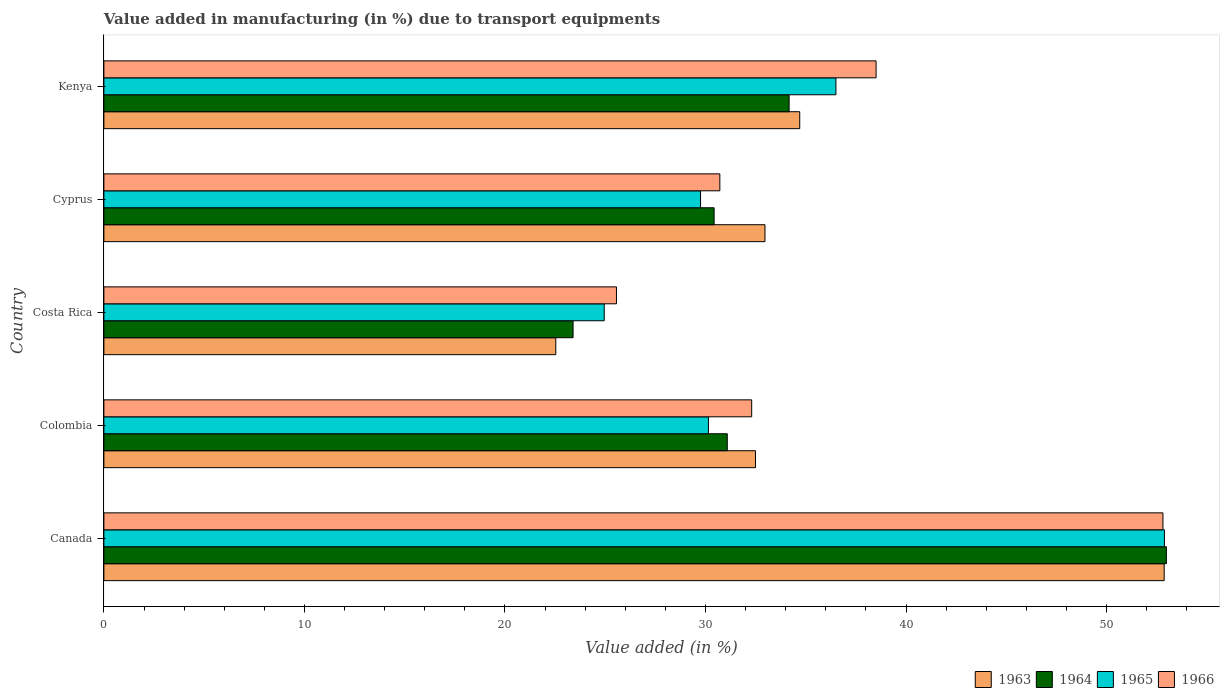How many bars are there on the 2nd tick from the top?
Provide a short and direct response. 4. How many bars are there on the 2nd tick from the bottom?
Give a very brief answer. 4. What is the percentage of value added in manufacturing due to transport equipments in 1964 in Canada?
Give a very brief answer. 52.98. Across all countries, what is the maximum percentage of value added in manufacturing due to transport equipments in 1964?
Offer a very short reply. 52.98. Across all countries, what is the minimum percentage of value added in manufacturing due to transport equipments in 1966?
Provide a short and direct response. 25.56. What is the total percentage of value added in manufacturing due to transport equipments in 1963 in the graph?
Provide a short and direct response. 175.57. What is the difference between the percentage of value added in manufacturing due to transport equipments in 1964 in Canada and that in Colombia?
Give a very brief answer. 21.9. What is the difference between the percentage of value added in manufacturing due to transport equipments in 1966 in Colombia and the percentage of value added in manufacturing due to transport equipments in 1965 in Kenya?
Offer a terse response. -4.2. What is the average percentage of value added in manufacturing due to transport equipments in 1963 per country?
Provide a succinct answer. 35.11. What is the difference between the percentage of value added in manufacturing due to transport equipments in 1963 and percentage of value added in manufacturing due to transport equipments in 1964 in Kenya?
Give a very brief answer. 0.53. What is the ratio of the percentage of value added in manufacturing due to transport equipments in 1965 in Canada to that in Cyprus?
Your answer should be very brief. 1.78. What is the difference between the highest and the second highest percentage of value added in manufacturing due to transport equipments in 1964?
Make the answer very short. 18.81. What is the difference between the highest and the lowest percentage of value added in manufacturing due to transport equipments in 1963?
Provide a short and direct response. 30.34. What does the 4th bar from the top in Canada represents?
Offer a very short reply. 1963. Are all the bars in the graph horizontal?
Your response must be concise. Yes. How many countries are there in the graph?
Your answer should be compact. 5. Does the graph contain any zero values?
Keep it short and to the point. No. Does the graph contain grids?
Provide a short and direct response. No. How many legend labels are there?
Your response must be concise. 4. What is the title of the graph?
Your answer should be compact. Value added in manufacturing (in %) due to transport equipments. Does "2011" appear as one of the legend labels in the graph?
Your response must be concise. No. What is the label or title of the X-axis?
Offer a very short reply. Value added (in %). What is the label or title of the Y-axis?
Provide a short and direct response. Country. What is the Value added (in %) in 1963 in Canada?
Your response must be concise. 52.87. What is the Value added (in %) of 1964 in Canada?
Provide a short and direct response. 52.98. What is the Value added (in %) in 1965 in Canada?
Your answer should be compact. 52.89. What is the Value added (in %) of 1966 in Canada?
Provide a short and direct response. 52.81. What is the Value added (in %) of 1963 in Colombia?
Keep it short and to the point. 32.49. What is the Value added (in %) of 1964 in Colombia?
Your answer should be compact. 31.09. What is the Value added (in %) of 1965 in Colombia?
Your answer should be compact. 30.15. What is the Value added (in %) of 1966 in Colombia?
Offer a terse response. 32.3. What is the Value added (in %) in 1963 in Costa Rica?
Provide a short and direct response. 22.53. What is the Value added (in %) in 1964 in Costa Rica?
Provide a short and direct response. 23.4. What is the Value added (in %) in 1965 in Costa Rica?
Ensure brevity in your answer.  24.95. What is the Value added (in %) of 1966 in Costa Rica?
Provide a short and direct response. 25.56. What is the Value added (in %) of 1963 in Cyprus?
Offer a terse response. 32.97. What is the Value added (in %) in 1964 in Cyprus?
Provide a short and direct response. 30.43. What is the Value added (in %) in 1965 in Cyprus?
Ensure brevity in your answer.  29.75. What is the Value added (in %) in 1966 in Cyprus?
Ensure brevity in your answer.  30.72. What is the Value added (in %) of 1963 in Kenya?
Offer a very short reply. 34.7. What is the Value added (in %) of 1964 in Kenya?
Your answer should be very brief. 34.17. What is the Value added (in %) in 1965 in Kenya?
Make the answer very short. 36.5. What is the Value added (in %) in 1966 in Kenya?
Your response must be concise. 38.51. Across all countries, what is the maximum Value added (in %) in 1963?
Offer a terse response. 52.87. Across all countries, what is the maximum Value added (in %) in 1964?
Offer a terse response. 52.98. Across all countries, what is the maximum Value added (in %) of 1965?
Provide a succinct answer. 52.89. Across all countries, what is the maximum Value added (in %) in 1966?
Provide a short and direct response. 52.81. Across all countries, what is the minimum Value added (in %) of 1963?
Your answer should be very brief. 22.53. Across all countries, what is the minimum Value added (in %) in 1964?
Your answer should be very brief. 23.4. Across all countries, what is the minimum Value added (in %) of 1965?
Provide a short and direct response. 24.95. Across all countries, what is the minimum Value added (in %) in 1966?
Your response must be concise. 25.56. What is the total Value added (in %) in 1963 in the graph?
Your answer should be compact. 175.57. What is the total Value added (in %) of 1964 in the graph?
Your answer should be very brief. 172.06. What is the total Value added (in %) of 1965 in the graph?
Your answer should be very brief. 174.24. What is the total Value added (in %) of 1966 in the graph?
Provide a short and direct response. 179.9. What is the difference between the Value added (in %) of 1963 in Canada and that in Colombia?
Make the answer very short. 20.38. What is the difference between the Value added (in %) in 1964 in Canada and that in Colombia?
Provide a succinct answer. 21.9. What is the difference between the Value added (in %) in 1965 in Canada and that in Colombia?
Give a very brief answer. 22.74. What is the difference between the Value added (in %) in 1966 in Canada and that in Colombia?
Offer a terse response. 20.51. What is the difference between the Value added (in %) in 1963 in Canada and that in Costa Rica?
Your answer should be compact. 30.34. What is the difference between the Value added (in %) in 1964 in Canada and that in Costa Rica?
Ensure brevity in your answer.  29.59. What is the difference between the Value added (in %) in 1965 in Canada and that in Costa Rica?
Offer a very short reply. 27.93. What is the difference between the Value added (in %) in 1966 in Canada and that in Costa Rica?
Provide a succinct answer. 27.25. What is the difference between the Value added (in %) in 1963 in Canada and that in Cyprus?
Ensure brevity in your answer.  19.91. What is the difference between the Value added (in %) of 1964 in Canada and that in Cyprus?
Ensure brevity in your answer.  22.55. What is the difference between the Value added (in %) of 1965 in Canada and that in Cyprus?
Offer a very short reply. 23.13. What is the difference between the Value added (in %) in 1966 in Canada and that in Cyprus?
Keep it short and to the point. 22.1. What is the difference between the Value added (in %) in 1963 in Canada and that in Kenya?
Keep it short and to the point. 18.17. What is the difference between the Value added (in %) of 1964 in Canada and that in Kenya?
Offer a terse response. 18.81. What is the difference between the Value added (in %) of 1965 in Canada and that in Kenya?
Keep it short and to the point. 16.38. What is the difference between the Value added (in %) of 1966 in Canada and that in Kenya?
Provide a succinct answer. 14.3. What is the difference between the Value added (in %) in 1963 in Colombia and that in Costa Rica?
Provide a short and direct response. 9.96. What is the difference between the Value added (in %) of 1964 in Colombia and that in Costa Rica?
Your response must be concise. 7.69. What is the difference between the Value added (in %) in 1965 in Colombia and that in Costa Rica?
Your response must be concise. 5.2. What is the difference between the Value added (in %) of 1966 in Colombia and that in Costa Rica?
Your response must be concise. 6.74. What is the difference between the Value added (in %) in 1963 in Colombia and that in Cyprus?
Your answer should be very brief. -0.47. What is the difference between the Value added (in %) in 1964 in Colombia and that in Cyprus?
Provide a short and direct response. 0.66. What is the difference between the Value added (in %) of 1965 in Colombia and that in Cyprus?
Your response must be concise. 0.39. What is the difference between the Value added (in %) of 1966 in Colombia and that in Cyprus?
Your answer should be compact. 1.59. What is the difference between the Value added (in %) in 1963 in Colombia and that in Kenya?
Your response must be concise. -2.21. What is the difference between the Value added (in %) of 1964 in Colombia and that in Kenya?
Offer a very short reply. -3.08. What is the difference between the Value added (in %) of 1965 in Colombia and that in Kenya?
Make the answer very short. -6.36. What is the difference between the Value added (in %) of 1966 in Colombia and that in Kenya?
Keep it short and to the point. -6.2. What is the difference between the Value added (in %) in 1963 in Costa Rica and that in Cyprus?
Keep it short and to the point. -10.43. What is the difference between the Value added (in %) in 1964 in Costa Rica and that in Cyprus?
Make the answer very short. -7.03. What is the difference between the Value added (in %) in 1965 in Costa Rica and that in Cyprus?
Ensure brevity in your answer.  -4.8. What is the difference between the Value added (in %) in 1966 in Costa Rica and that in Cyprus?
Your answer should be compact. -5.16. What is the difference between the Value added (in %) in 1963 in Costa Rica and that in Kenya?
Offer a very short reply. -12.17. What is the difference between the Value added (in %) of 1964 in Costa Rica and that in Kenya?
Give a very brief answer. -10.77. What is the difference between the Value added (in %) in 1965 in Costa Rica and that in Kenya?
Your response must be concise. -11.55. What is the difference between the Value added (in %) in 1966 in Costa Rica and that in Kenya?
Give a very brief answer. -12.95. What is the difference between the Value added (in %) of 1963 in Cyprus and that in Kenya?
Offer a very short reply. -1.73. What is the difference between the Value added (in %) in 1964 in Cyprus and that in Kenya?
Give a very brief answer. -3.74. What is the difference between the Value added (in %) of 1965 in Cyprus and that in Kenya?
Ensure brevity in your answer.  -6.75. What is the difference between the Value added (in %) of 1966 in Cyprus and that in Kenya?
Your response must be concise. -7.79. What is the difference between the Value added (in %) in 1963 in Canada and the Value added (in %) in 1964 in Colombia?
Provide a succinct answer. 21.79. What is the difference between the Value added (in %) in 1963 in Canada and the Value added (in %) in 1965 in Colombia?
Keep it short and to the point. 22.73. What is the difference between the Value added (in %) of 1963 in Canada and the Value added (in %) of 1966 in Colombia?
Ensure brevity in your answer.  20.57. What is the difference between the Value added (in %) in 1964 in Canada and the Value added (in %) in 1965 in Colombia?
Offer a very short reply. 22.84. What is the difference between the Value added (in %) in 1964 in Canada and the Value added (in %) in 1966 in Colombia?
Provide a succinct answer. 20.68. What is the difference between the Value added (in %) in 1965 in Canada and the Value added (in %) in 1966 in Colombia?
Ensure brevity in your answer.  20.58. What is the difference between the Value added (in %) in 1963 in Canada and the Value added (in %) in 1964 in Costa Rica?
Ensure brevity in your answer.  29.48. What is the difference between the Value added (in %) in 1963 in Canada and the Value added (in %) in 1965 in Costa Rica?
Give a very brief answer. 27.92. What is the difference between the Value added (in %) in 1963 in Canada and the Value added (in %) in 1966 in Costa Rica?
Your answer should be compact. 27.31. What is the difference between the Value added (in %) in 1964 in Canada and the Value added (in %) in 1965 in Costa Rica?
Offer a terse response. 28.03. What is the difference between the Value added (in %) in 1964 in Canada and the Value added (in %) in 1966 in Costa Rica?
Your response must be concise. 27.42. What is the difference between the Value added (in %) of 1965 in Canada and the Value added (in %) of 1966 in Costa Rica?
Make the answer very short. 27.33. What is the difference between the Value added (in %) in 1963 in Canada and the Value added (in %) in 1964 in Cyprus?
Offer a very short reply. 22.44. What is the difference between the Value added (in %) of 1963 in Canada and the Value added (in %) of 1965 in Cyprus?
Give a very brief answer. 23.12. What is the difference between the Value added (in %) in 1963 in Canada and the Value added (in %) in 1966 in Cyprus?
Provide a short and direct response. 22.16. What is the difference between the Value added (in %) of 1964 in Canada and the Value added (in %) of 1965 in Cyprus?
Ensure brevity in your answer.  23.23. What is the difference between the Value added (in %) in 1964 in Canada and the Value added (in %) in 1966 in Cyprus?
Provide a succinct answer. 22.27. What is the difference between the Value added (in %) of 1965 in Canada and the Value added (in %) of 1966 in Cyprus?
Give a very brief answer. 22.17. What is the difference between the Value added (in %) in 1963 in Canada and the Value added (in %) in 1964 in Kenya?
Make the answer very short. 18.7. What is the difference between the Value added (in %) of 1963 in Canada and the Value added (in %) of 1965 in Kenya?
Your answer should be very brief. 16.37. What is the difference between the Value added (in %) of 1963 in Canada and the Value added (in %) of 1966 in Kenya?
Ensure brevity in your answer.  14.37. What is the difference between the Value added (in %) in 1964 in Canada and the Value added (in %) in 1965 in Kenya?
Give a very brief answer. 16.48. What is the difference between the Value added (in %) in 1964 in Canada and the Value added (in %) in 1966 in Kenya?
Your answer should be very brief. 14.47. What is the difference between the Value added (in %) in 1965 in Canada and the Value added (in %) in 1966 in Kenya?
Offer a very short reply. 14.38. What is the difference between the Value added (in %) in 1963 in Colombia and the Value added (in %) in 1964 in Costa Rica?
Provide a succinct answer. 9.1. What is the difference between the Value added (in %) of 1963 in Colombia and the Value added (in %) of 1965 in Costa Rica?
Provide a succinct answer. 7.54. What is the difference between the Value added (in %) in 1963 in Colombia and the Value added (in %) in 1966 in Costa Rica?
Offer a terse response. 6.93. What is the difference between the Value added (in %) in 1964 in Colombia and the Value added (in %) in 1965 in Costa Rica?
Ensure brevity in your answer.  6.14. What is the difference between the Value added (in %) of 1964 in Colombia and the Value added (in %) of 1966 in Costa Rica?
Provide a short and direct response. 5.53. What is the difference between the Value added (in %) in 1965 in Colombia and the Value added (in %) in 1966 in Costa Rica?
Provide a succinct answer. 4.59. What is the difference between the Value added (in %) in 1963 in Colombia and the Value added (in %) in 1964 in Cyprus?
Your response must be concise. 2.06. What is the difference between the Value added (in %) in 1963 in Colombia and the Value added (in %) in 1965 in Cyprus?
Ensure brevity in your answer.  2.74. What is the difference between the Value added (in %) in 1963 in Colombia and the Value added (in %) in 1966 in Cyprus?
Provide a short and direct response. 1.78. What is the difference between the Value added (in %) of 1964 in Colombia and the Value added (in %) of 1965 in Cyprus?
Provide a succinct answer. 1.33. What is the difference between the Value added (in %) in 1964 in Colombia and the Value added (in %) in 1966 in Cyprus?
Ensure brevity in your answer.  0.37. What is the difference between the Value added (in %) of 1965 in Colombia and the Value added (in %) of 1966 in Cyprus?
Your answer should be very brief. -0.57. What is the difference between the Value added (in %) of 1963 in Colombia and the Value added (in %) of 1964 in Kenya?
Your answer should be very brief. -1.68. What is the difference between the Value added (in %) of 1963 in Colombia and the Value added (in %) of 1965 in Kenya?
Offer a very short reply. -4.01. What is the difference between the Value added (in %) in 1963 in Colombia and the Value added (in %) in 1966 in Kenya?
Your answer should be very brief. -6.01. What is the difference between the Value added (in %) of 1964 in Colombia and the Value added (in %) of 1965 in Kenya?
Give a very brief answer. -5.42. What is the difference between the Value added (in %) of 1964 in Colombia and the Value added (in %) of 1966 in Kenya?
Keep it short and to the point. -7.42. What is the difference between the Value added (in %) of 1965 in Colombia and the Value added (in %) of 1966 in Kenya?
Ensure brevity in your answer.  -8.36. What is the difference between the Value added (in %) in 1963 in Costa Rica and the Value added (in %) in 1964 in Cyprus?
Offer a very short reply. -7.9. What is the difference between the Value added (in %) of 1963 in Costa Rica and the Value added (in %) of 1965 in Cyprus?
Offer a very short reply. -7.22. What is the difference between the Value added (in %) of 1963 in Costa Rica and the Value added (in %) of 1966 in Cyprus?
Your answer should be very brief. -8.18. What is the difference between the Value added (in %) of 1964 in Costa Rica and the Value added (in %) of 1965 in Cyprus?
Your answer should be compact. -6.36. What is the difference between the Value added (in %) of 1964 in Costa Rica and the Value added (in %) of 1966 in Cyprus?
Provide a short and direct response. -7.32. What is the difference between the Value added (in %) of 1965 in Costa Rica and the Value added (in %) of 1966 in Cyprus?
Give a very brief answer. -5.77. What is the difference between the Value added (in %) in 1963 in Costa Rica and the Value added (in %) in 1964 in Kenya?
Give a very brief answer. -11.64. What is the difference between the Value added (in %) in 1963 in Costa Rica and the Value added (in %) in 1965 in Kenya?
Provide a short and direct response. -13.97. What is the difference between the Value added (in %) of 1963 in Costa Rica and the Value added (in %) of 1966 in Kenya?
Your response must be concise. -15.97. What is the difference between the Value added (in %) of 1964 in Costa Rica and the Value added (in %) of 1965 in Kenya?
Your answer should be compact. -13.11. What is the difference between the Value added (in %) of 1964 in Costa Rica and the Value added (in %) of 1966 in Kenya?
Your answer should be compact. -15.11. What is the difference between the Value added (in %) in 1965 in Costa Rica and the Value added (in %) in 1966 in Kenya?
Your answer should be very brief. -13.56. What is the difference between the Value added (in %) in 1963 in Cyprus and the Value added (in %) in 1964 in Kenya?
Give a very brief answer. -1.2. What is the difference between the Value added (in %) of 1963 in Cyprus and the Value added (in %) of 1965 in Kenya?
Make the answer very short. -3.54. What is the difference between the Value added (in %) in 1963 in Cyprus and the Value added (in %) in 1966 in Kenya?
Keep it short and to the point. -5.54. What is the difference between the Value added (in %) in 1964 in Cyprus and the Value added (in %) in 1965 in Kenya?
Your answer should be very brief. -6.07. What is the difference between the Value added (in %) in 1964 in Cyprus and the Value added (in %) in 1966 in Kenya?
Provide a short and direct response. -8.08. What is the difference between the Value added (in %) in 1965 in Cyprus and the Value added (in %) in 1966 in Kenya?
Your answer should be very brief. -8.75. What is the average Value added (in %) in 1963 per country?
Your answer should be compact. 35.11. What is the average Value added (in %) in 1964 per country?
Keep it short and to the point. 34.41. What is the average Value added (in %) of 1965 per country?
Your answer should be compact. 34.85. What is the average Value added (in %) of 1966 per country?
Provide a short and direct response. 35.98. What is the difference between the Value added (in %) of 1963 and Value added (in %) of 1964 in Canada?
Provide a succinct answer. -0.11. What is the difference between the Value added (in %) in 1963 and Value added (in %) in 1965 in Canada?
Offer a terse response. -0.01. What is the difference between the Value added (in %) in 1963 and Value added (in %) in 1966 in Canada?
Ensure brevity in your answer.  0.06. What is the difference between the Value added (in %) in 1964 and Value added (in %) in 1965 in Canada?
Your answer should be very brief. 0.1. What is the difference between the Value added (in %) of 1964 and Value added (in %) of 1966 in Canada?
Offer a terse response. 0.17. What is the difference between the Value added (in %) in 1965 and Value added (in %) in 1966 in Canada?
Your answer should be very brief. 0.07. What is the difference between the Value added (in %) of 1963 and Value added (in %) of 1964 in Colombia?
Keep it short and to the point. 1.41. What is the difference between the Value added (in %) in 1963 and Value added (in %) in 1965 in Colombia?
Provide a succinct answer. 2.35. What is the difference between the Value added (in %) in 1963 and Value added (in %) in 1966 in Colombia?
Your response must be concise. 0.19. What is the difference between the Value added (in %) of 1964 and Value added (in %) of 1965 in Colombia?
Make the answer very short. 0.94. What is the difference between the Value added (in %) of 1964 and Value added (in %) of 1966 in Colombia?
Provide a succinct answer. -1.22. What is the difference between the Value added (in %) in 1965 and Value added (in %) in 1966 in Colombia?
Offer a very short reply. -2.16. What is the difference between the Value added (in %) in 1963 and Value added (in %) in 1964 in Costa Rica?
Keep it short and to the point. -0.86. What is the difference between the Value added (in %) of 1963 and Value added (in %) of 1965 in Costa Rica?
Your answer should be compact. -2.42. What is the difference between the Value added (in %) of 1963 and Value added (in %) of 1966 in Costa Rica?
Provide a short and direct response. -3.03. What is the difference between the Value added (in %) in 1964 and Value added (in %) in 1965 in Costa Rica?
Provide a succinct answer. -1.55. What is the difference between the Value added (in %) of 1964 and Value added (in %) of 1966 in Costa Rica?
Make the answer very short. -2.16. What is the difference between the Value added (in %) of 1965 and Value added (in %) of 1966 in Costa Rica?
Give a very brief answer. -0.61. What is the difference between the Value added (in %) of 1963 and Value added (in %) of 1964 in Cyprus?
Your response must be concise. 2.54. What is the difference between the Value added (in %) in 1963 and Value added (in %) in 1965 in Cyprus?
Provide a short and direct response. 3.21. What is the difference between the Value added (in %) in 1963 and Value added (in %) in 1966 in Cyprus?
Your response must be concise. 2.25. What is the difference between the Value added (in %) in 1964 and Value added (in %) in 1965 in Cyprus?
Make the answer very short. 0.68. What is the difference between the Value added (in %) of 1964 and Value added (in %) of 1966 in Cyprus?
Make the answer very short. -0.29. What is the difference between the Value added (in %) in 1965 and Value added (in %) in 1966 in Cyprus?
Give a very brief answer. -0.96. What is the difference between the Value added (in %) of 1963 and Value added (in %) of 1964 in Kenya?
Your answer should be compact. 0.53. What is the difference between the Value added (in %) in 1963 and Value added (in %) in 1965 in Kenya?
Ensure brevity in your answer.  -1.8. What is the difference between the Value added (in %) of 1963 and Value added (in %) of 1966 in Kenya?
Give a very brief answer. -3.81. What is the difference between the Value added (in %) in 1964 and Value added (in %) in 1965 in Kenya?
Give a very brief answer. -2.33. What is the difference between the Value added (in %) of 1964 and Value added (in %) of 1966 in Kenya?
Your answer should be very brief. -4.34. What is the difference between the Value added (in %) of 1965 and Value added (in %) of 1966 in Kenya?
Give a very brief answer. -2. What is the ratio of the Value added (in %) in 1963 in Canada to that in Colombia?
Give a very brief answer. 1.63. What is the ratio of the Value added (in %) in 1964 in Canada to that in Colombia?
Offer a very short reply. 1.7. What is the ratio of the Value added (in %) of 1965 in Canada to that in Colombia?
Your answer should be compact. 1.75. What is the ratio of the Value added (in %) in 1966 in Canada to that in Colombia?
Ensure brevity in your answer.  1.63. What is the ratio of the Value added (in %) of 1963 in Canada to that in Costa Rica?
Make the answer very short. 2.35. What is the ratio of the Value added (in %) in 1964 in Canada to that in Costa Rica?
Keep it short and to the point. 2.26. What is the ratio of the Value added (in %) of 1965 in Canada to that in Costa Rica?
Your response must be concise. 2.12. What is the ratio of the Value added (in %) of 1966 in Canada to that in Costa Rica?
Keep it short and to the point. 2.07. What is the ratio of the Value added (in %) of 1963 in Canada to that in Cyprus?
Offer a very short reply. 1.6. What is the ratio of the Value added (in %) of 1964 in Canada to that in Cyprus?
Make the answer very short. 1.74. What is the ratio of the Value added (in %) of 1965 in Canada to that in Cyprus?
Offer a very short reply. 1.78. What is the ratio of the Value added (in %) of 1966 in Canada to that in Cyprus?
Your response must be concise. 1.72. What is the ratio of the Value added (in %) of 1963 in Canada to that in Kenya?
Your answer should be very brief. 1.52. What is the ratio of the Value added (in %) of 1964 in Canada to that in Kenya?
Provide a succinct answer. 1.55. What is the ratio of the Value added (in %) in 1965 in Canada to that in Kenya?
Provide a short and direct response. 1.45. What is the ratio of the Value added (in %) of 1966 in Canada to that in Kenya?
Your answer should be compact. 1.37. What is the ratio of the Value added (in %) in 1963 in Colombia to that in Costa Rica?
Ensure brevity in your answer.  1.44. What is the ratio of the Value added (in %) in 1964 in Colombia to that in Costa Rica?
Give a very brief answer. 1.33. What is the ratio of the Value added (in %) in 1965 in Colombia to that in Costa Rica?
Keep it short and to the point. 1.21. What is the ratio of the Value added (in %) in 1966 in Colombia to that in Costa Rica?
Provide a succinct answer. 1.26. What is the ratio of the Value added (in %) of 1963 in Colombia to that in Cyprus?
Keep it short and to the point. 0.99. What is the ratio of the Value added (in %) of 1964 in Colombia to that in Cyprus?
Your answer should be compact. 1.02. What is the ratio of the Value added (in %) in 1965 in Colombia to that in Cyprus?
Your answer should be very brief. 1.01. What is the ratio of the Value added (in %) of 1966 in Colombia to that in Cyprus?
Provide a short and direct response. 1.05. What is the ratio of the Value added (in %) in 1963 in Colombia to that in Kenya?
Your answer should be compact. 0.94. What is the ratio of the Value added (in %) in 1964 in Colombia to that in Kenya?
Your answer should be compact. 0.91. What is the ratio of the Value added (in %) in 1965 in Colombia to that in Kenya?
Make the answer very short. 0.83. What is the ratio of the Value added (in %) in 1966 in Colombia to that in Kenya?
Make the answer very short. 0.84. What is the ratio of the Value added (in %) in 1963 in Costa Rica to that in Cyprus?
Offer a very short reply. 0.68. What is the ratio of the Value added (in %) of 1964 in Costa Rica to that in Cyprus?
Your answer should be very brief. 0.77. What is the ratio of the Value added (in %) in 1965 in Costa Rica to that in Cyprus?
Give a very brief answer. 0.84. What is the ratio of the Value added (in %) in 1966 in Costa Rica to that in Cyprus?
Your response must be concise. 0.83. What is the ratio of the Value added (in %) in 1963 in Costa Rica to that in Kenya?
Your answer should be compact. 0.65. What is the ratio of the Value added (in %) in 1964 in Costa Rica to that in Kenya?
Your response must be concise. 0.68. What is the ratio of the Value added (in %) in 1965 in Costa Rica to that in Kenya?
Your response must be concise. 0.68. What is the ratio of the Value added (in %) of 1966 in Costa Rica to that in Kenya?
Your answer should be compact. 0.66. What is the ratio of the Value added (in %) of 1963 in Cyprus to that in Kenya?
Offer a very short reply. 0.95. What is the ratio of the Value added (in %) of 1964 in Cyprus to that in Kenya?
Ensure brevity in your answer.  0.89. What is the ratio of the Value added (in %) in 1965 in Cyprus to that in Kenya?
Offer a very short reply. 0.82. What is the ratio of the Value added (in %) in 1966 in Cyprus to that in Kenya?
Your response must be concise. 0.8. What is the difference between the highest and the second highest Value added (in %) in 1963?
Offer a very short reply. 18.17. What is the difference between the highest and the second highest Value added (in %) of 1964?
Keep it short and to the point. 18.81. What is the difference between the highest and the second highest Value added (in %) in 1965?
Provide a short and direct response. 16.38. What is the difference between the highest and the second highest Value added (in %) of 1966?
Give a very brief answer. 14.3. What is the difference between the highest and the lowest Value added (in %) of 1963?
Keep it short and to the point. 30.34. What is the difference between the highest and the lowest Value added (in %) in 1964?
Provide a short and direct response. 29.59. What is the difference between the highest and the lowest Value added (in %) of 1965?
Offer a terse response. 27.93. What is the difference between the highest and the lowest Value added (in %) in 1966?
Ensure brevity in your answer.  27.25. 